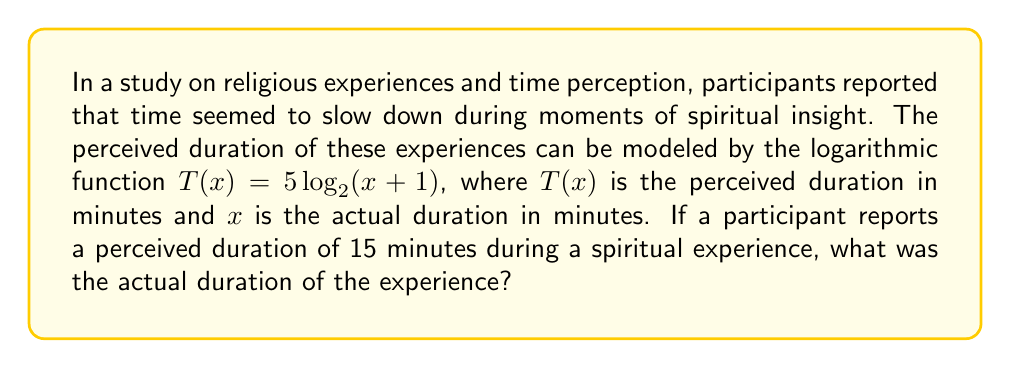Give your solution to this math problem. Let's approach this step-by-step:

1) We are given the function $T(x) = 5 \log_2(x + 1)$, where:
   $T(x)$ is the perceived duration in minutes
   $x$ is the actual duration in minutes

2) We need to find $x$ when $T(x) = 15$ minutes. Let's substitute this into our equation:

   $15 = 5 \log_2(x + 1)$

3) First, let's divide both sides by 5:

   $3 = \log_2(x + 1)$

4) Now, we need to solve for $x$. We can do this by applying the inverse function of $\log_2$, which is $2^y$:

   $2^3 = x + 1$

5) Simplify the left side:

   $8 = x + 1$

6) Subtract 1 from both sides to isolate $x$:

   $7 = x$

Therefore, the actual duration of the experience was 7 minutes.

This logarithmic model reflects the philosophical concept that intense spiritual experiences can alter our perception of time, making brief moments feel much longer - a phenomenon that aligns with existentialist ideas about the subjective nature of human experience.
Answer: 7 minutes 